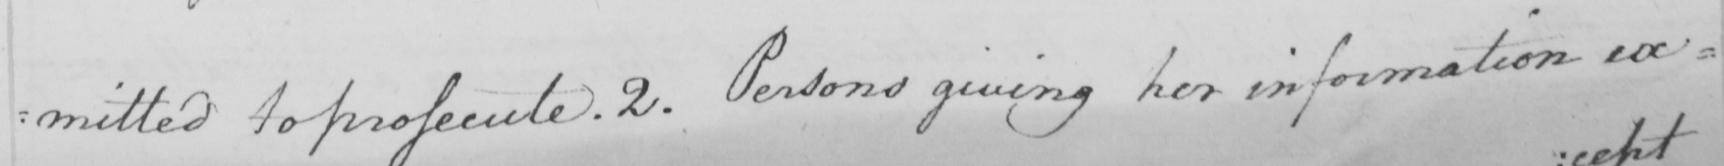What does this handwritten line say? : mitted to prosecute . 2 . Persons giving her information ex= 